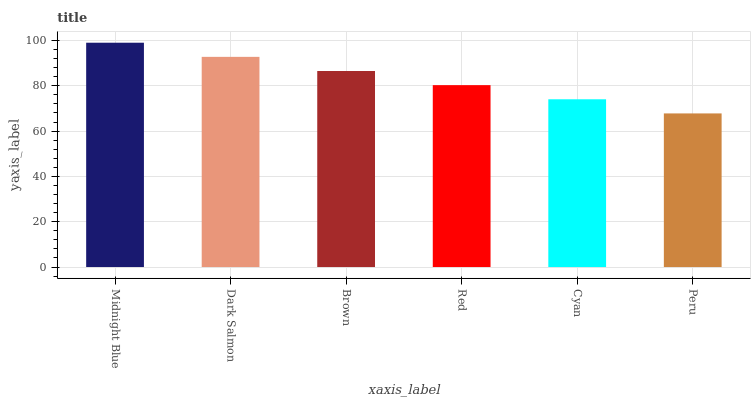Is Peru the minimum?
Answer yes or no. Yes. Is Midnight Blue the maximum?
Answer yes or no. Yes. Is Dark Salmon the minimum?
Answer yes or no. No. Is Dark Salmon the maximum?
Answer yes or no. No. Is Midnight Blue greater than Dark Salmon?
Answer yes or no. Yes. Is Dark Salmon less than Midnight Blue?
Answer yes or no. Yes. Is Dark Salmon greater than Midnight Blue?
Answer yes or no. No. Is Midnight Blue less than Dark Salmon?
Answer yes or no. No. Is Brown the high median?
Answer yes or no. Yes. Is Red the low median?
Answer yes or no. Yes. Is Red the high median?
Answer yes or no. No. Is Midnight Blue the low median?
Answer yes or no. No. 